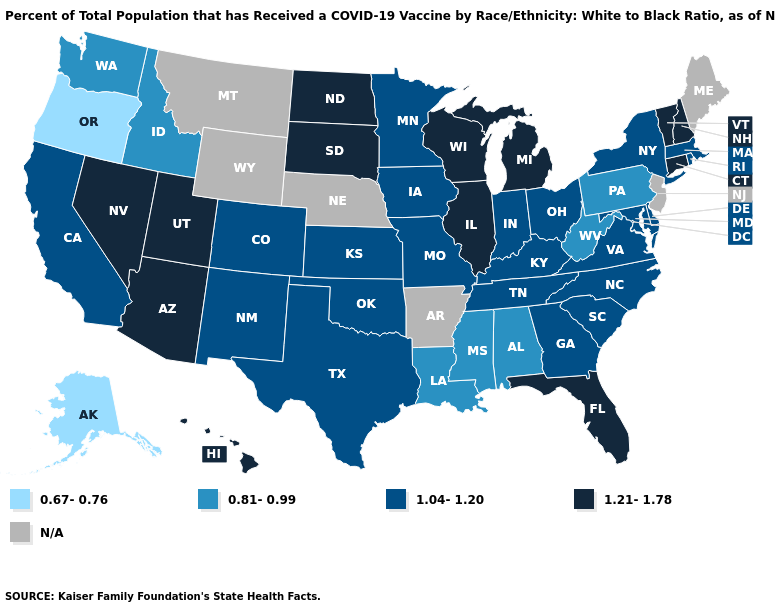How many symbols are there in the legend?
Answer briefly. 5. What is the lowest value in states that border Idaho?
Short answer required. 0.67-0.76. What is the lowest value in the USA?
Write a very short answer. 0.67-0.76. Among the states that border Washington , which have the lowest value?
Short answer required. Oregon. How many symbols are there in the legend?
Write a very short answer. 5. Does California have the lowest value in the West?
Answer briefly. No. What is the highest value in states that border Tennessee?
Quick response, please. 1.04-1.20. What is the highest value in the USA?
Answer briefly. 1.21-1.78. Name the states that have a value in the range 1.21-1.78?
Write a very short answer. Arizona, Connecticut, Florida, Hawaii, Illinois, Michigan, Nevada, New Hampshire, North Dakota, South Dakota, Utah, Vermont, Wisconsin. What is the value of Florida?
Keep it brief. 1.21-1.78. What is the value of Louisiana?
Answer briefly. 0.81-0.99. Does the first symbol in the legend represent the smallest category?
Short answer required. Yes. How many symbols are there in the legend?
Short answer required. 5. How many symbols are there in the legend?
Be succinct. 5. 